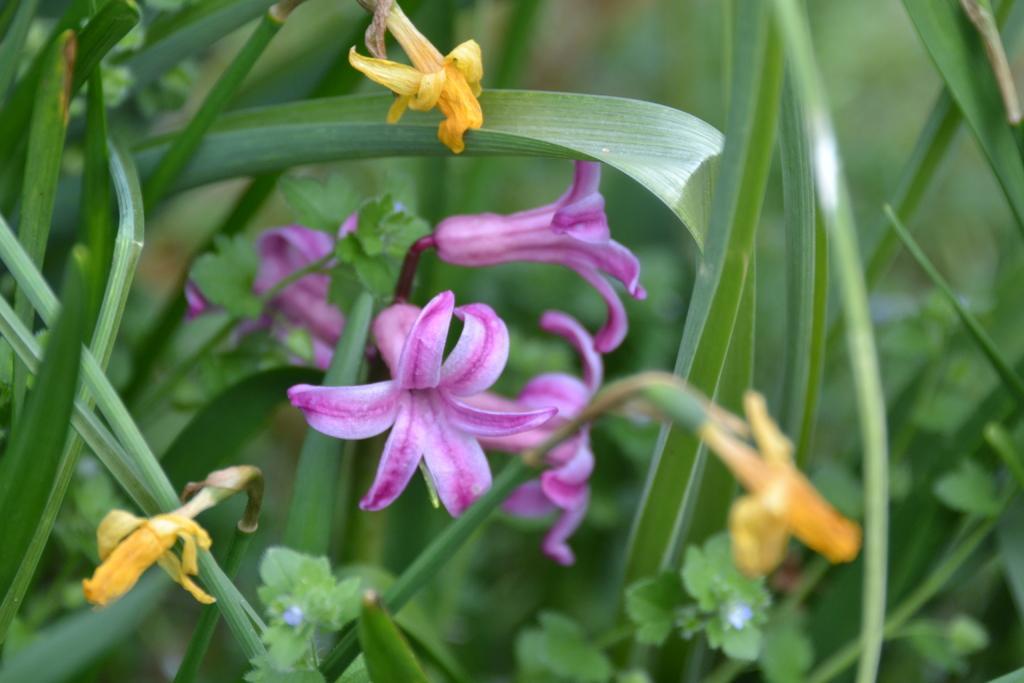Please provide a concise description of this image. In this image we can see there are some flowers, leaves of a plant and grass. 